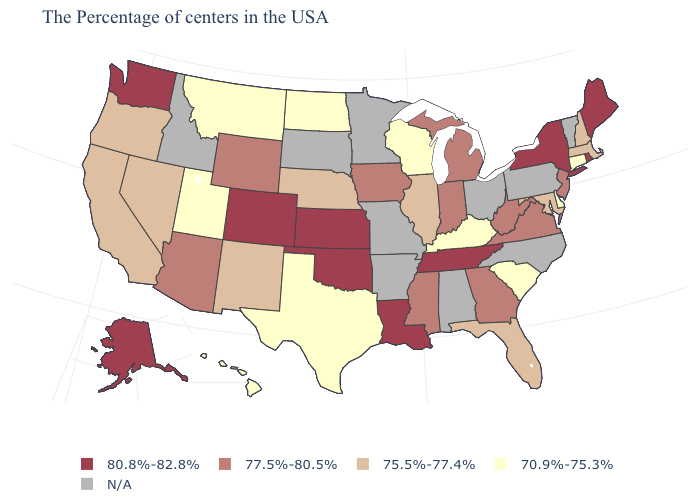Among the states that border Vermont , does Massachusetts have the lowest value?
Be succinct. Yes. Does Alaska have the highest value in the USA?
Keep it brief. Yes. Name the states that have a value in the range N/A?
Be succinct. Vermont, Pennsylvania, North Carolina, Ohio, Alabama, Missouri, Arkansas, Minnesota, South Dakota, Idaho. Name the states that have a value in the range 77.5%-80.5%?
Keep it brief. New Jersey, Virginia, West Virginia, Georgia, Michigan, Indiana, Mississippi, Iowa, Wyoming, Arizona. Does the first symbol in the legend represent the smallest category?
Be succinct. No. Does Kansas have the highest value in the USA?
Write a very short answer. Yes. Name the states that have a value in the range N/A?
Be succinct. Vermont, Pennsylvania, North Carolina, Ohio, Alabama, Missouri, Arkansas, Minnesota, South Dakota, Idaho. Which states have the highest value in the USA?
Write a very short answer. Maine, Rhode Island, New York, Tennessee, Louisiana, Kansas, Oklahoma, Colorado, Washington, Alaska. Is the legend a continuous bar?
Concise answer only. No. What is the value of Vermont?
Short answer required. N/A. Is the legend a continuous bar?
Give a very brief answer. No. What is the value of Arizona?
Be succinct. 77.5%-80.5%. Name the states that have a value in the range N/A?
Short answer required. Vermont, Pennsylvania, North Carolina, Ohio, Alabama, Missouri, Arkansas, Minnesota, South Dakota, Idaho. Does Alaska have the highest value in the USA?
Quick response, please. Yes. 